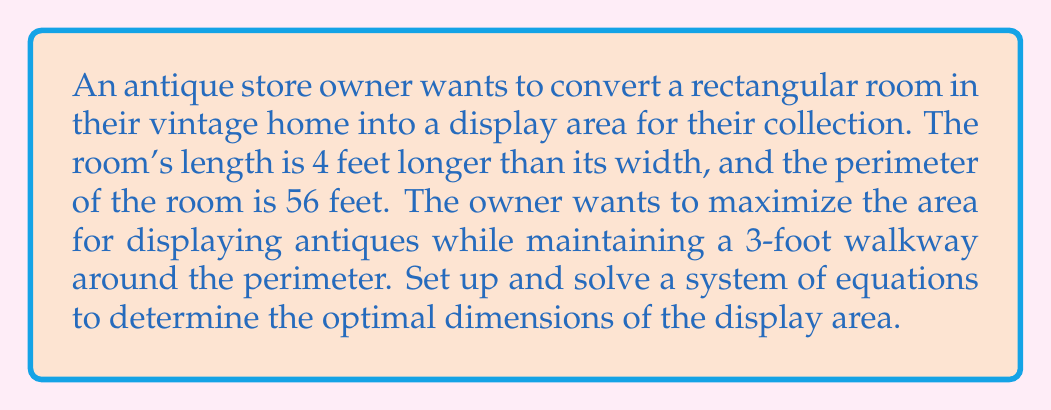Could you help me with this problem? Let's approach this step-by-step:

1) Let $w$ be the width of the room and $l$ be the length.

2) Given that the length is 4 feet longer than the width:
   $$l = w + 4$$

3) The perimeter of the room is 56 feet:
   $$2w + 2l = 56$$

4) Substitute the expression for $l$ into the perimeter equation:
   $$2w + 2(w + 4) = 56$$
   $$2w + 2w + 8 = 56$$
   $$4w + 8 = 56$$
   $$4w = 48$$
   $$w = 12$$

5) Now we can find $l$:
   $$l = w + 4 = 12 + 4 = 16$$

6) The room dimensions are 12 feet by 16 feet.

7) To find the display area, we need to subtract the 3-foot walkway from each side:
   Display width = $12 - (2 * 3) = 6$ feet
   Display length = $16 - (2 * 3) = 10$ feet

8) The optimal display area is:
   $$A = 6 * 10 = 60$$ square feet
Answer: $60\text{ ft}^2$ 